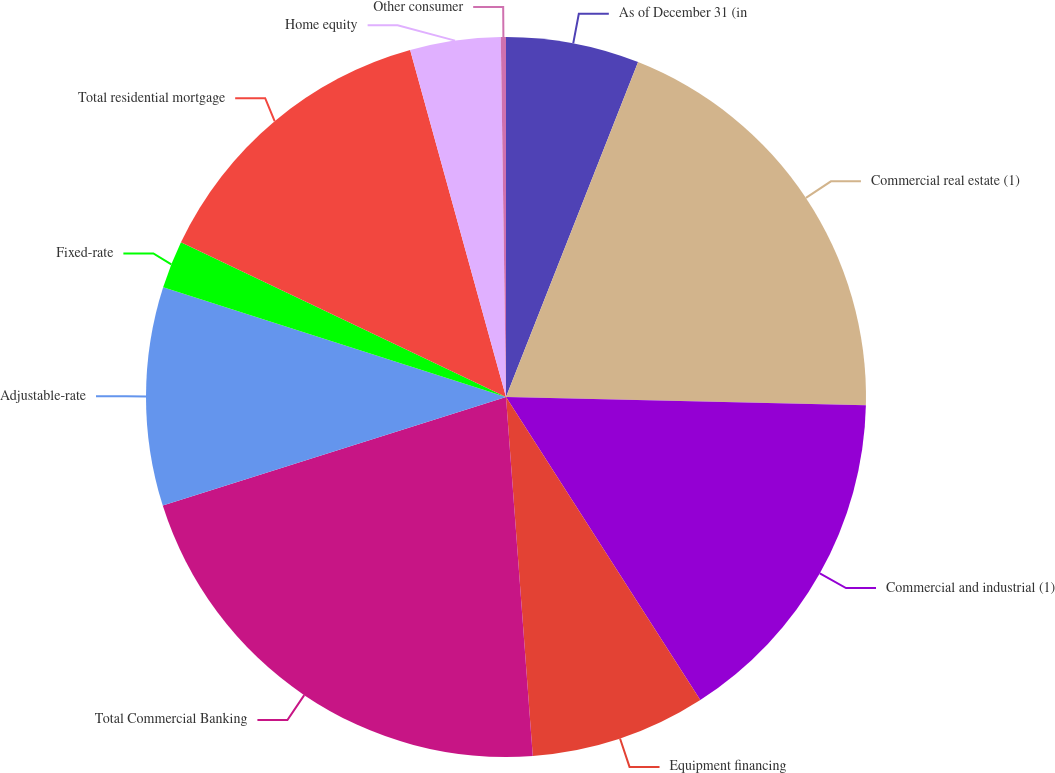<chart> <loc_0><loc_0><loc_500><loc_500><pie_chart><fcel>As of December 31 (in<fcel>Commercial real estate (1)<fcel>Commercial and industrial (1)<fcel>Equipment financing<fcel>Total Commercial Banking<fcel>Adjustable-rate<fcel>Fixed-rate<fcel>Total residential mortgage<fcel>Home equity<fcel>Other consumer<nl><fcel>5.98%<fcel>19.39%<fcel>15.56%<fcel>7.89%<fcel>21.31%<fcel>9.81%<fcel>2.14%<fcel>13.64%<fcel>4.06%<fcel>0.23%<nl></chart> 